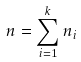<formula> <loc_0><loc_0><loc_500><loc_500>n = \sum _ { i = 1 } ^ { k } n _ { i }</formula> 